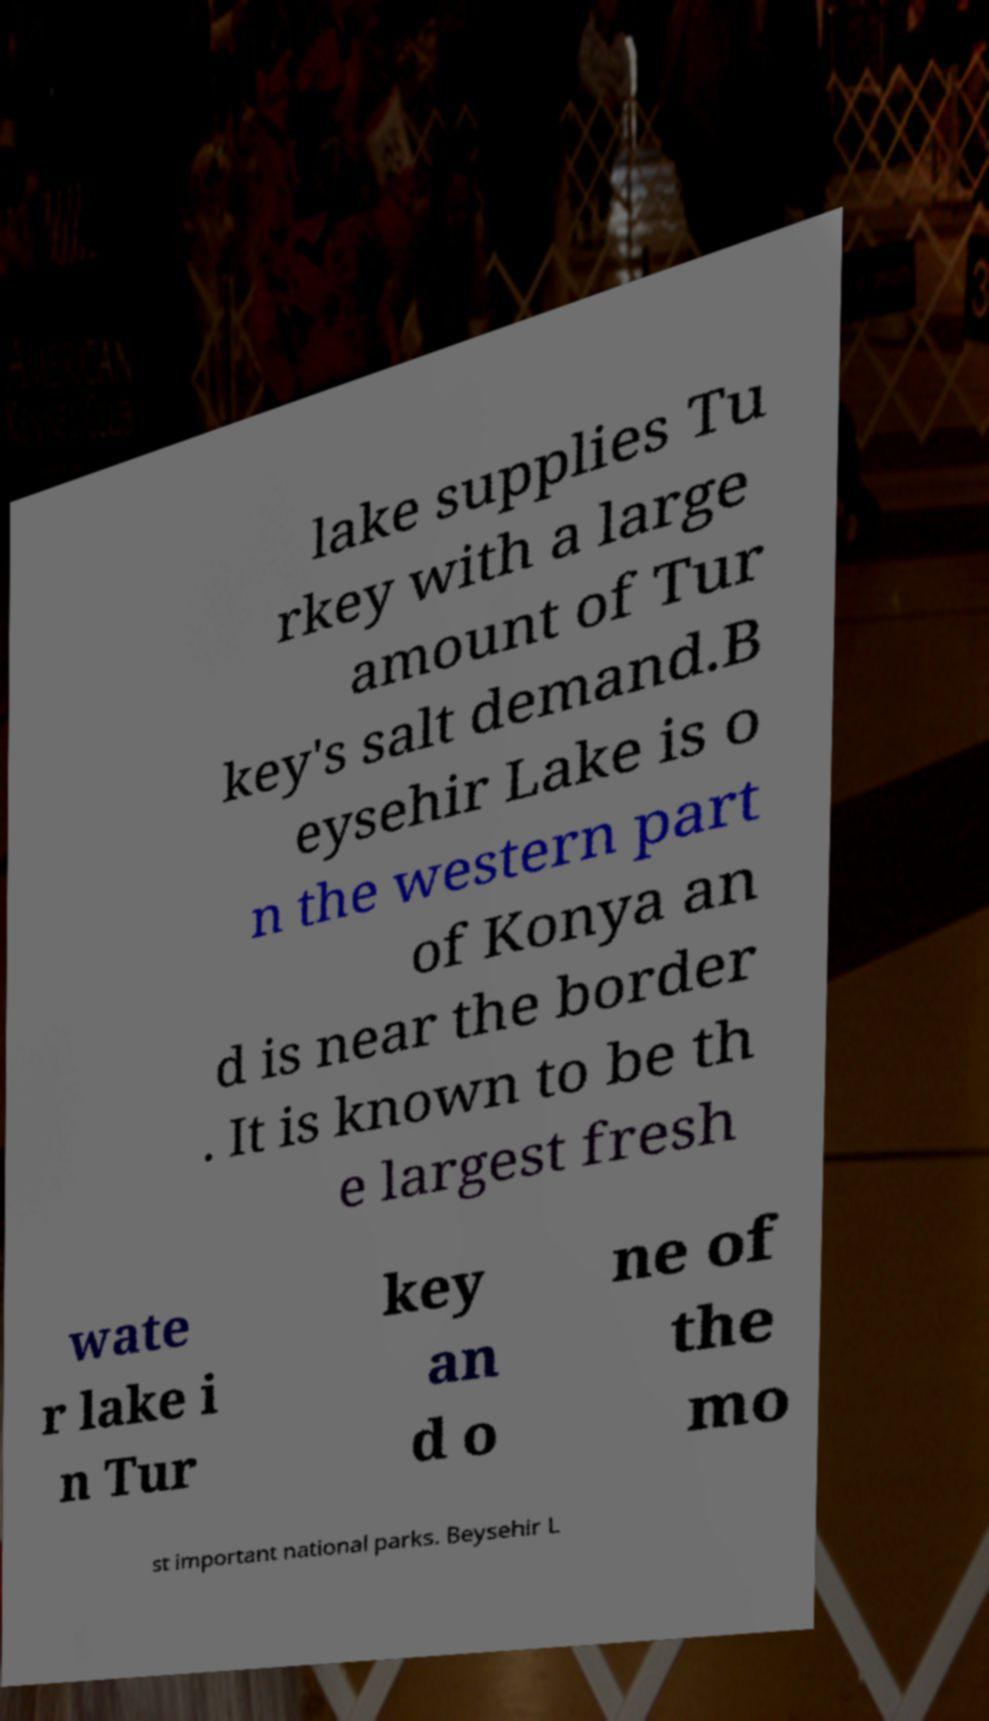Please read and relay the text visible in this image. What does it say? lake supplies Tu rkey with a large amount of Tur key's salt demand.B eysehir Lake is o n the western part of Konya an d is near the border . It is known to be th e largest fresh wate r lake i n Tur key an d o ne of the mo st important national parks. Beysehir L 